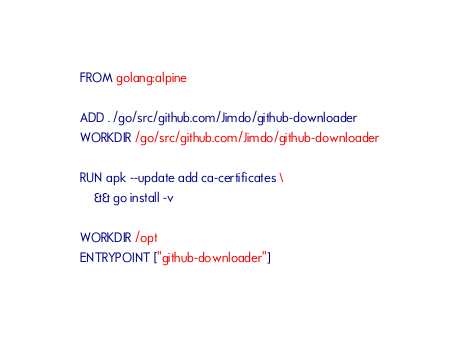<code> <loc_0><loc_0><loc_500><loc_500><_Dockerfile_>FROM golang:alpine

ADD . /go/src/github.com/Jimdo/github-downloader
WORKDIR /go/src/github.com/Jimdo/github-downloader

RUN apk --update add ca-certificates \
    && go install -v

WORKDIR /opt
ENTRYPOINT ["github-downloader"]
</code> 